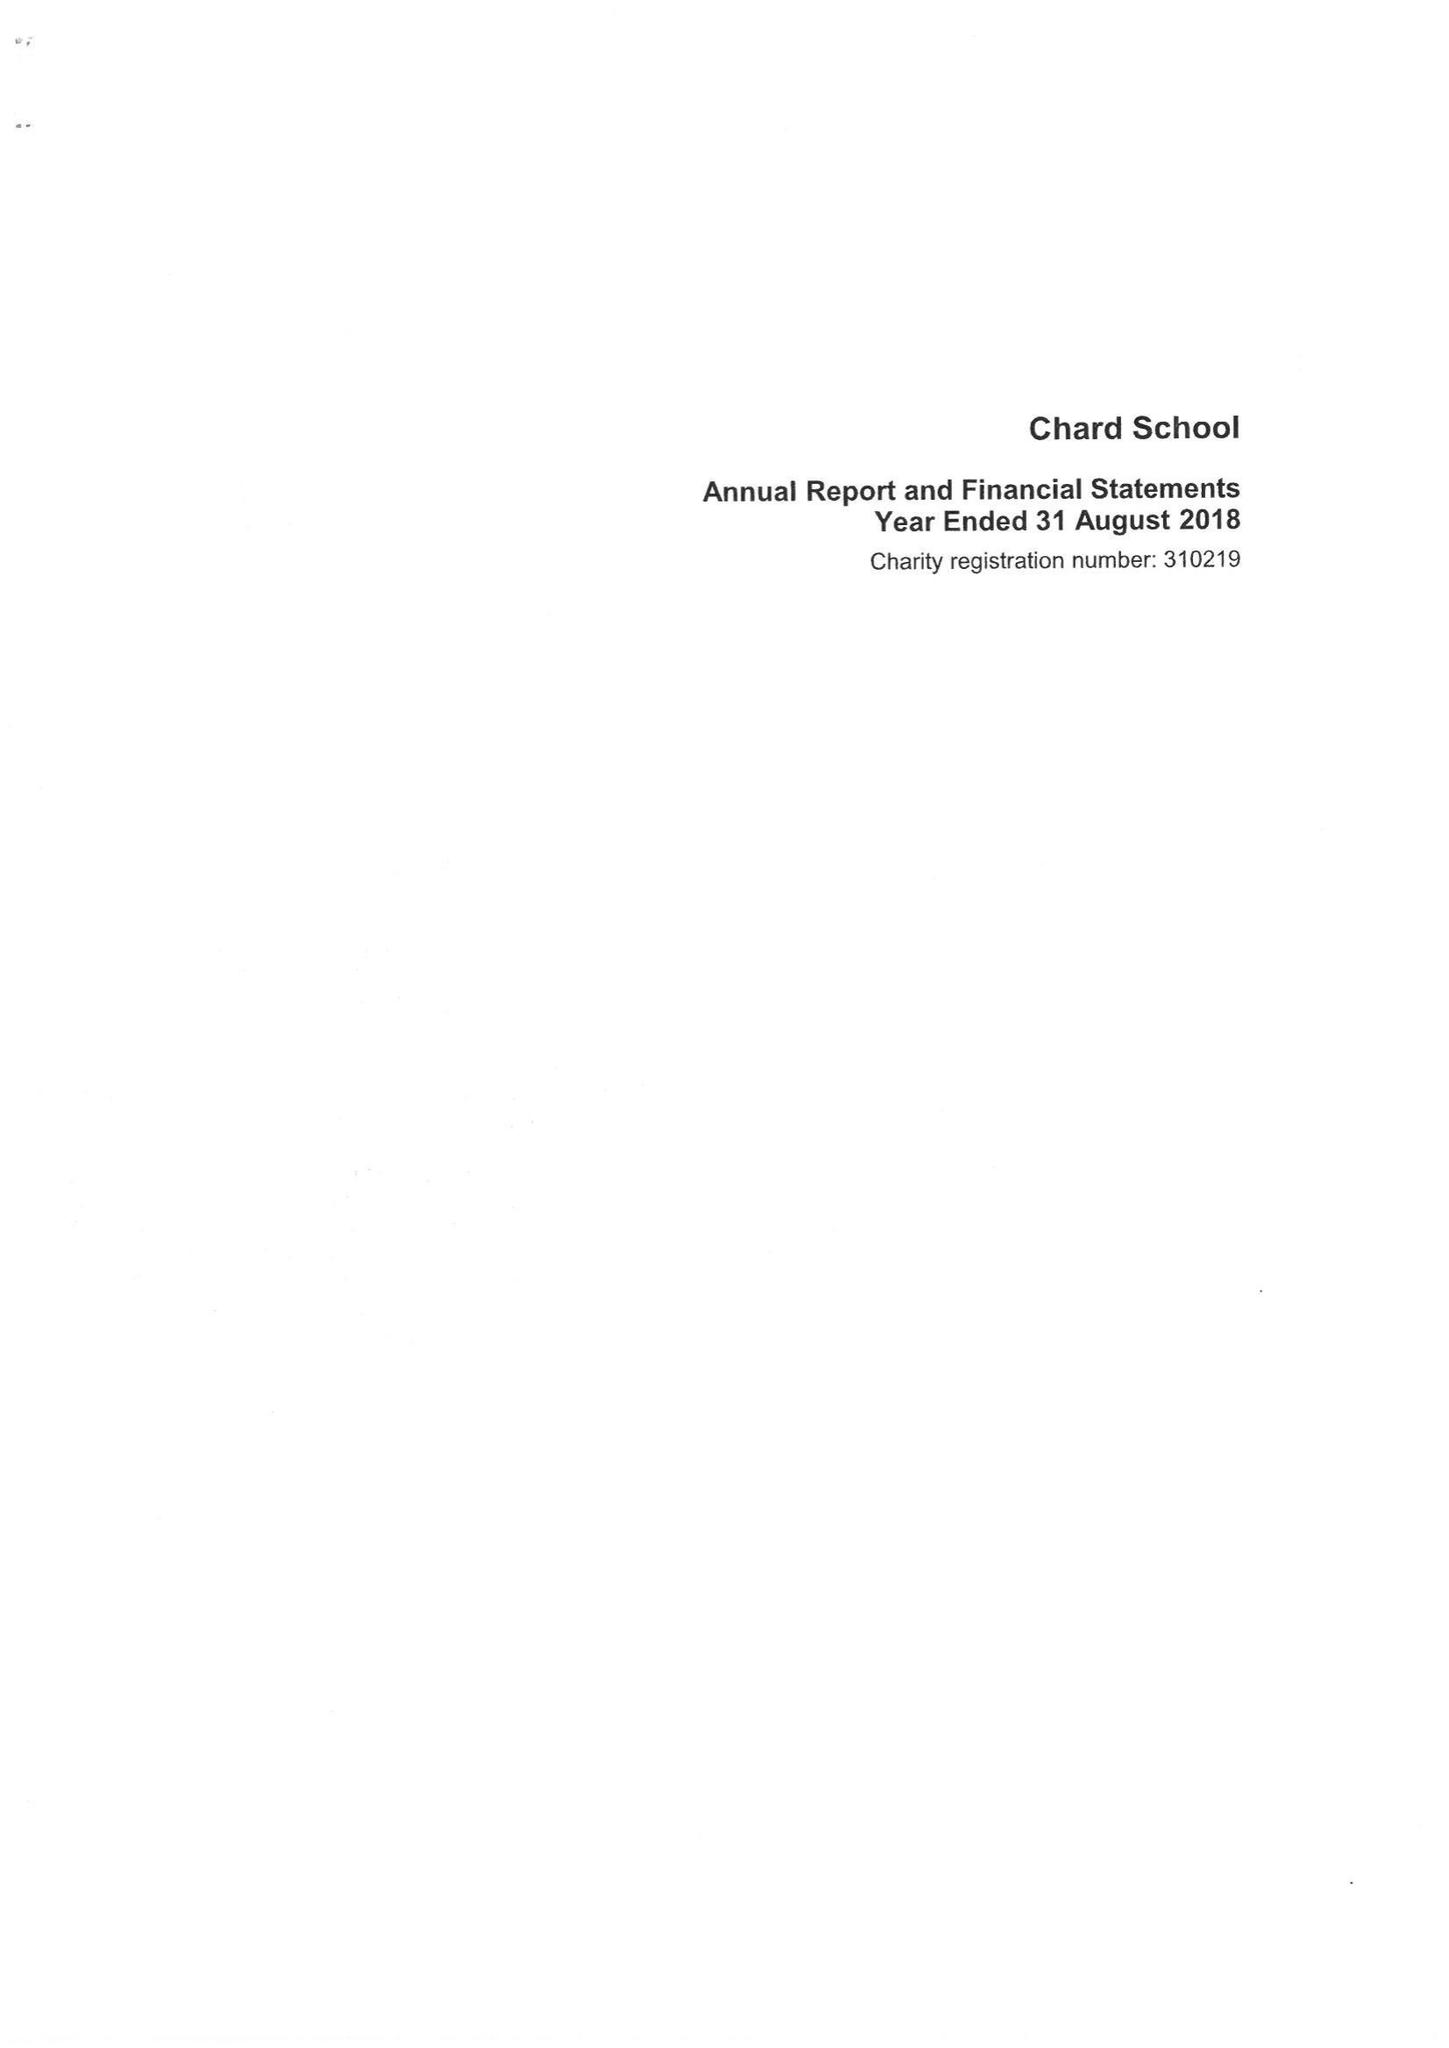What is the value for the address__street_line?
Answer the question using a single word or phrase. FORE STREET 